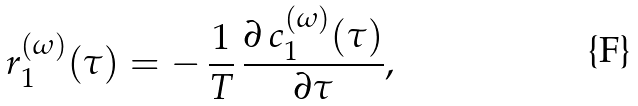<formula> <loc_0><loc_0><loc_500><loc_500>r _ { 1 } ^ { ( \omega ) } ( \tau ) = - \, \frac { 1 } { T } \, \frac { \partial \, c _ { 1 } ^ { ( \omega ) } ( \tau ) } { \partial \tau } ,</formula> 